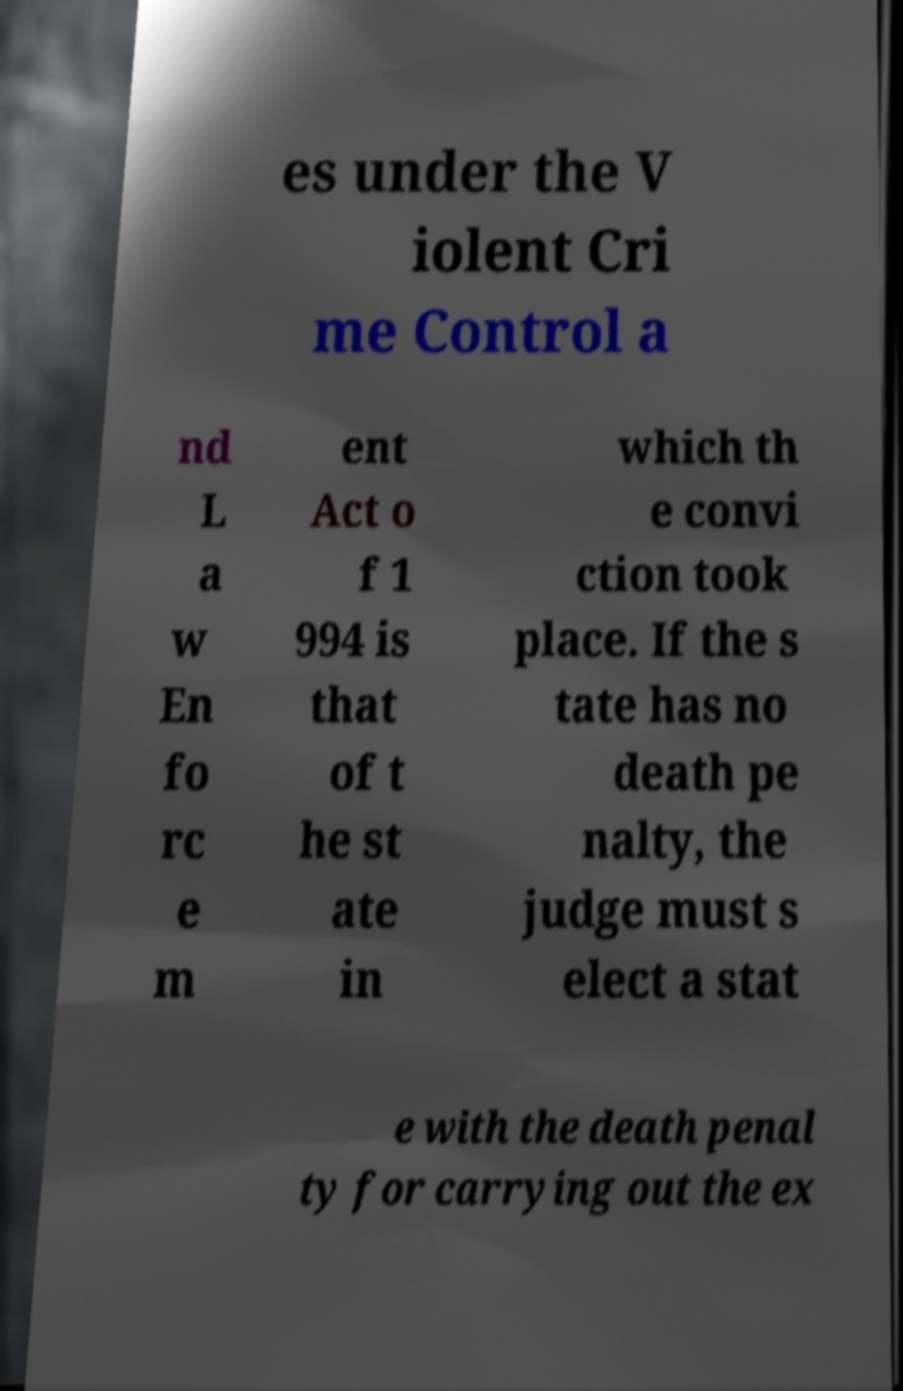Please identify and transcribe the text found in this image. es under the V iolent Cri me Control a nd L a w En fo rc e m ent Act o f 1 994 is that of t he st ate in which th e convi ction took place. If the s tate has no death pe nalty, the judge must s elect a stat e with the death penal ty for carrying out the ex 